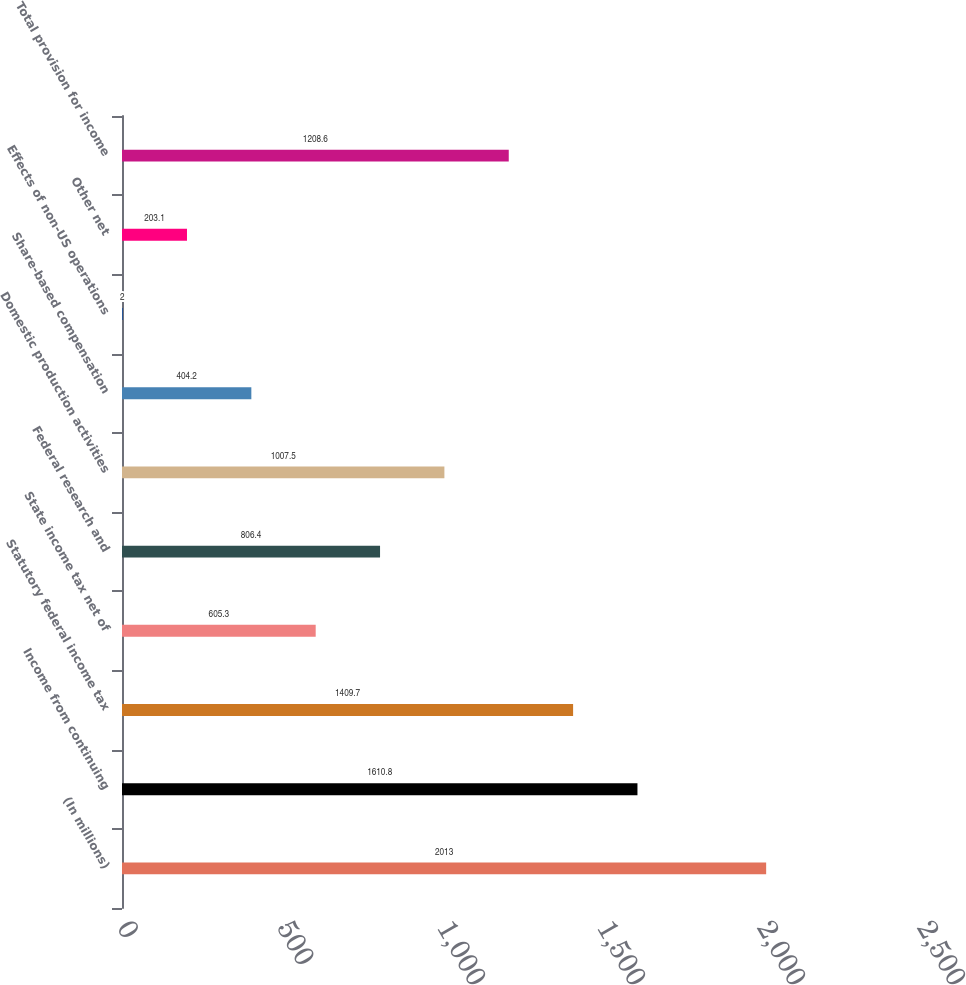Convert chart. <chart><loc_0><loc_0><loc_500><loc_500><bar_chart><fcel>(In millions)<fcel>Income from continuing<fcel>Statutory federal income tax<fcel>State income tax net of<fcel>Federal research and<fcel>Domestic production activities<fcel>Share-based compensation<fcel>Effects of non-US operations<fcel>Other net<fcel>Total provision for income<nl><fcel>2013<fcel>1610.8<fcel>1409.7<fcel>605.3<fcel>806.4<fcel>1007.5<fcel>404.2<fcel>2<fcel>203.1<fcel>1208.6<nl></chart> 